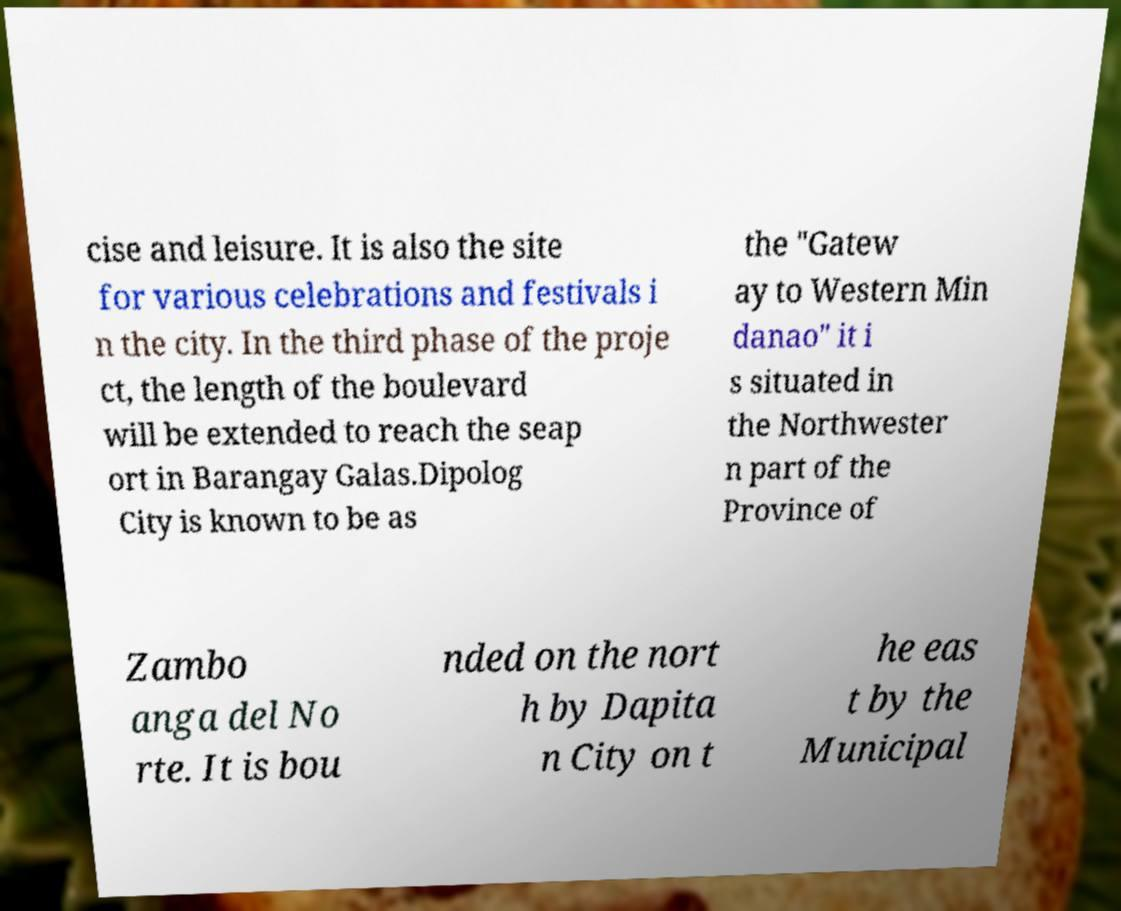I need the written content from this picture converted into text. Can you do that? cise and leisure. It is also the site for various celebrations and festivals i n the city. In the third phase of the proje ct, the length of the boulevard will be extended to reach the seap ort in Barangay Galas.Dipolog City is known to be as the "Gatew ay to Western Min danao" it i s situated in the Northwester n part of the Province of Zambo anga del No rte. It is bou nded on the nort h by Dapita n City on t he eas t by the Municipal 